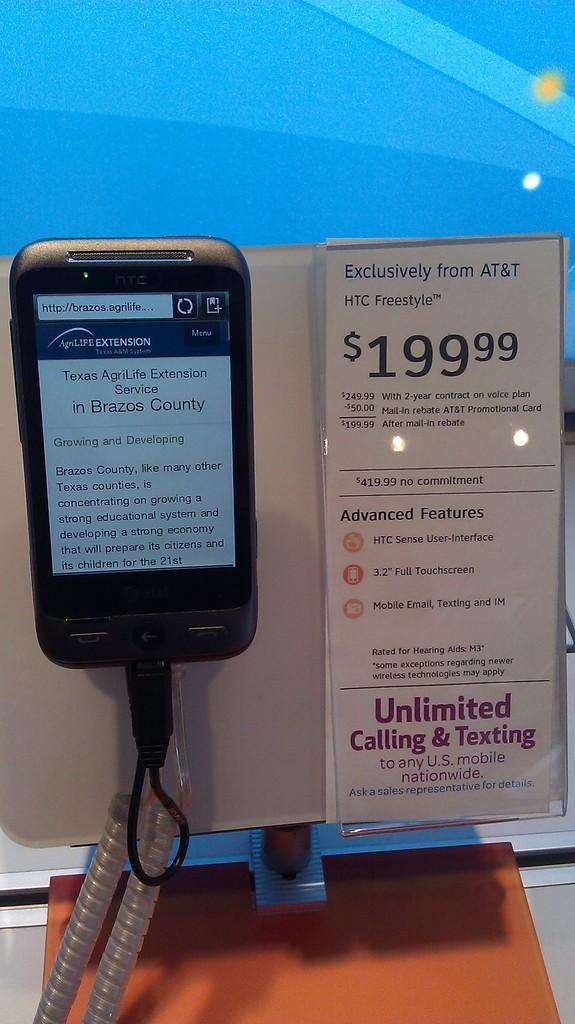<image>
Offer a succinct explanation of the picture presented. A display for a htc phone that advertises unlimited calling & texting. 